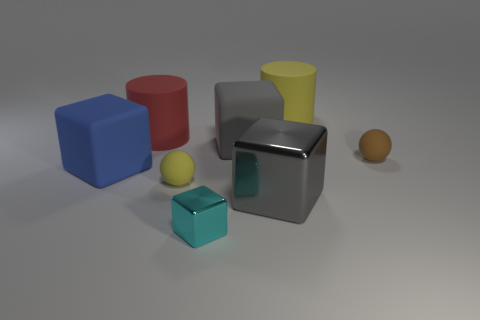Subtract all gray cubes. How many were subtracted if there are1gray cubes left? 1 Add 1 blue metallic spheres. How many objects exist? 9 Subtract all balls. How many objects are left? 6 Add 2 gray cubes. How many gray cubes exist? 4 Subtract 0 yellow blocks. How many objects are left? 8 Subtract all tiny shiny balls. Subtract all big red rubber objects. How many objects are left? 7 Add 3 tiny brown things. How many tiny brown things are left? 4 